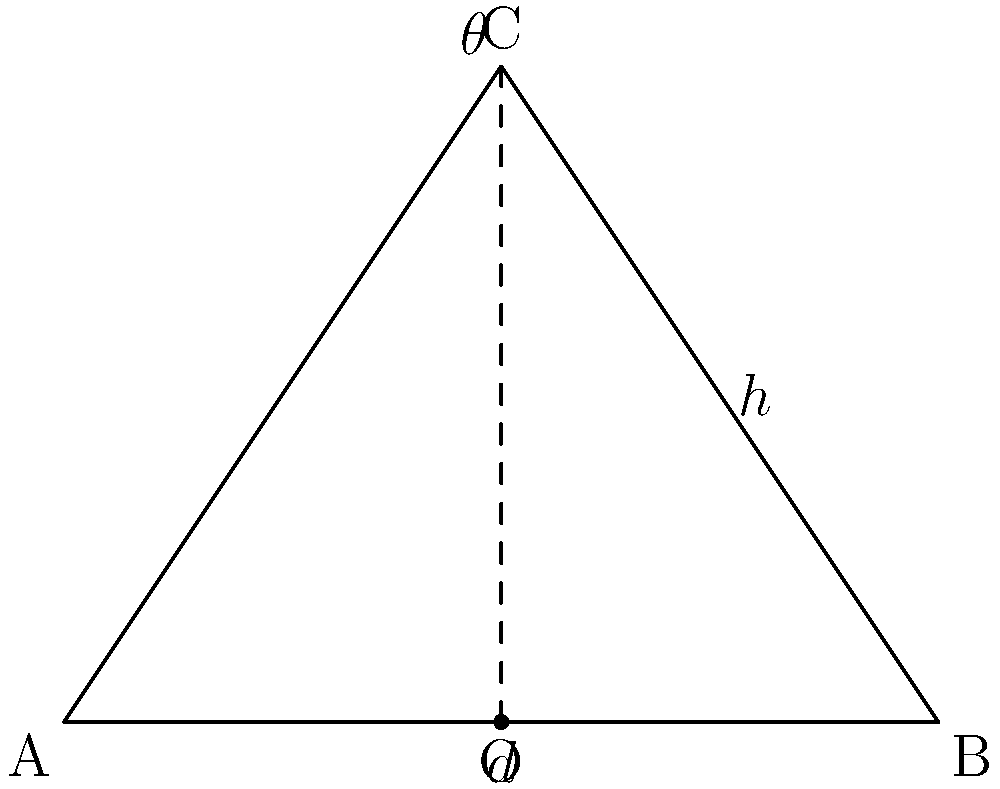As an aspiring photographer, you're experimenting with a wide-angle lens. The lens has a focal length of 24mm and a sensor width of 36mm. Using the diagram provided, where $d$ represents half the sensor width and $h$ represents the focal length, calculate the angle of view $\theta$ (in degrees) for this lens setup. To calculate the angle of view for a wide-angle lens, we can use the following steps:

1. Identify the given information:
   - Focal length ($h$) = 24mm
   - Sensor width = 36mm
   - Half sensor width ($d$) = 36mm ÷ 2 = 18mm

2. The triangle in the diagram represents half of the angle of view. We need to find $\theta$, which is the angle at the top of the triangle.

3. We can use the tangent function to relate the opposite side ($d$) to the adjacent side ($h$):

   $$\tan(\frac{\theta}{2}) = \frac{d}{h}$$

4. Substitute the known values:

   $$\tan(\frac{\theta}{2}) = \frac{18}{24} = 0.75$$

5. To solve for $\theta$, we need to use the inverse tangent (arctan) function and multiply by 2:

   $$\theta = 2 \cdot \arctan(0.75)$$

6. Calculate the result:

   $$\theta = 2 \cdot \arctan(0.75) \approx 2 \cdot 36.87° = 73.74°$$

7. Round to two decimal places:

   $$\theta \approx 73.74°$$

Thus, the angle of view for this wide-angle lens setup is approximately 73.74°.
Answer: 73.74° 